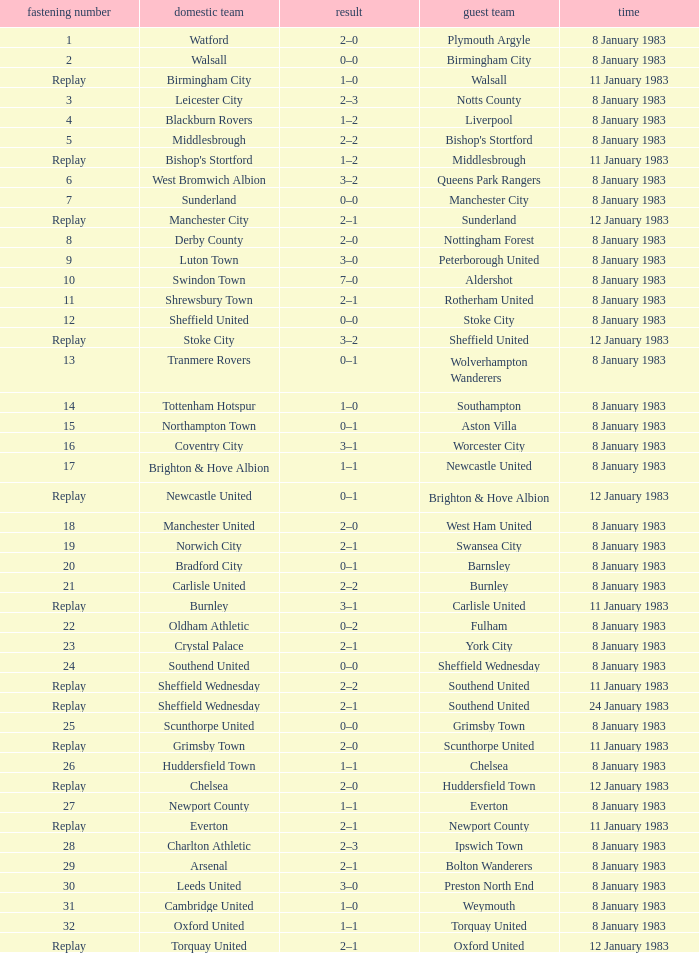What was the final score for the tie where Leeds United was the home team? 3–0. 